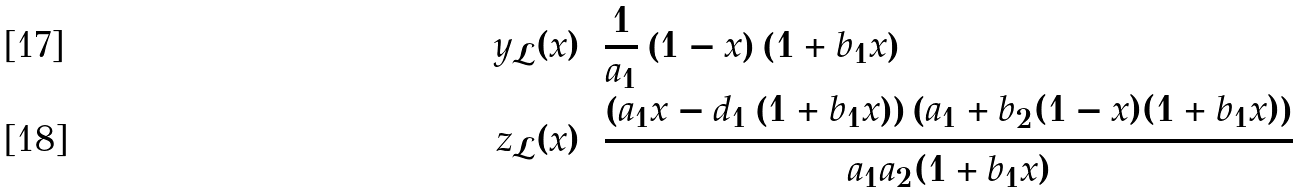Convert formula to latex. <formula><loc_0><loc_0><loc_500><loc_500>y _ { \mathcal { L } } ( x ) & = \frac { 1 } { a _ { 1 } } \left ( 1 - x \right ) \left ( 1 + b _ { 1 } x \right ) \\ z _ { \mathcal { L } } ( x ) & = \frac { \left ( a _ { 1 } x - d _ { 1 } \left ( 1 + b _ { 1 } x \right ) \right ) \left ( a _ { 1 } + b _ { 2 } ( 1 - x ) ( 1 + b _ { 1 } x ) \right ) } { a _ { 1 } a _ { 2 } ( 1 + b _ { 1 } x ) }</formula> 